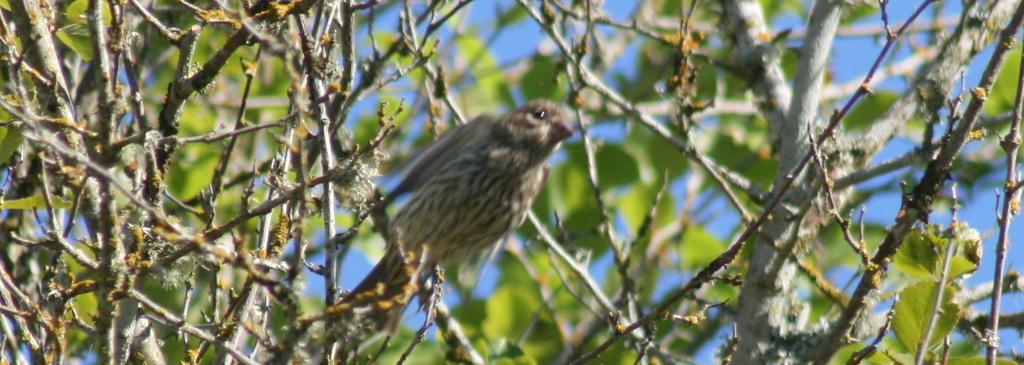What type of vegetation can be seen in the image? There are trees in the image. How are the trees depicted in the image? The trees appear to be truncated. Are there any animals visible in the image? Yes, there is a bird on one of the trees. What can be seen in the background of the image? The sky is visible in the background of the image. What type of celery is being used as a sheet on the seat in the image? There is no celery, sheet, or seat present in the image. 